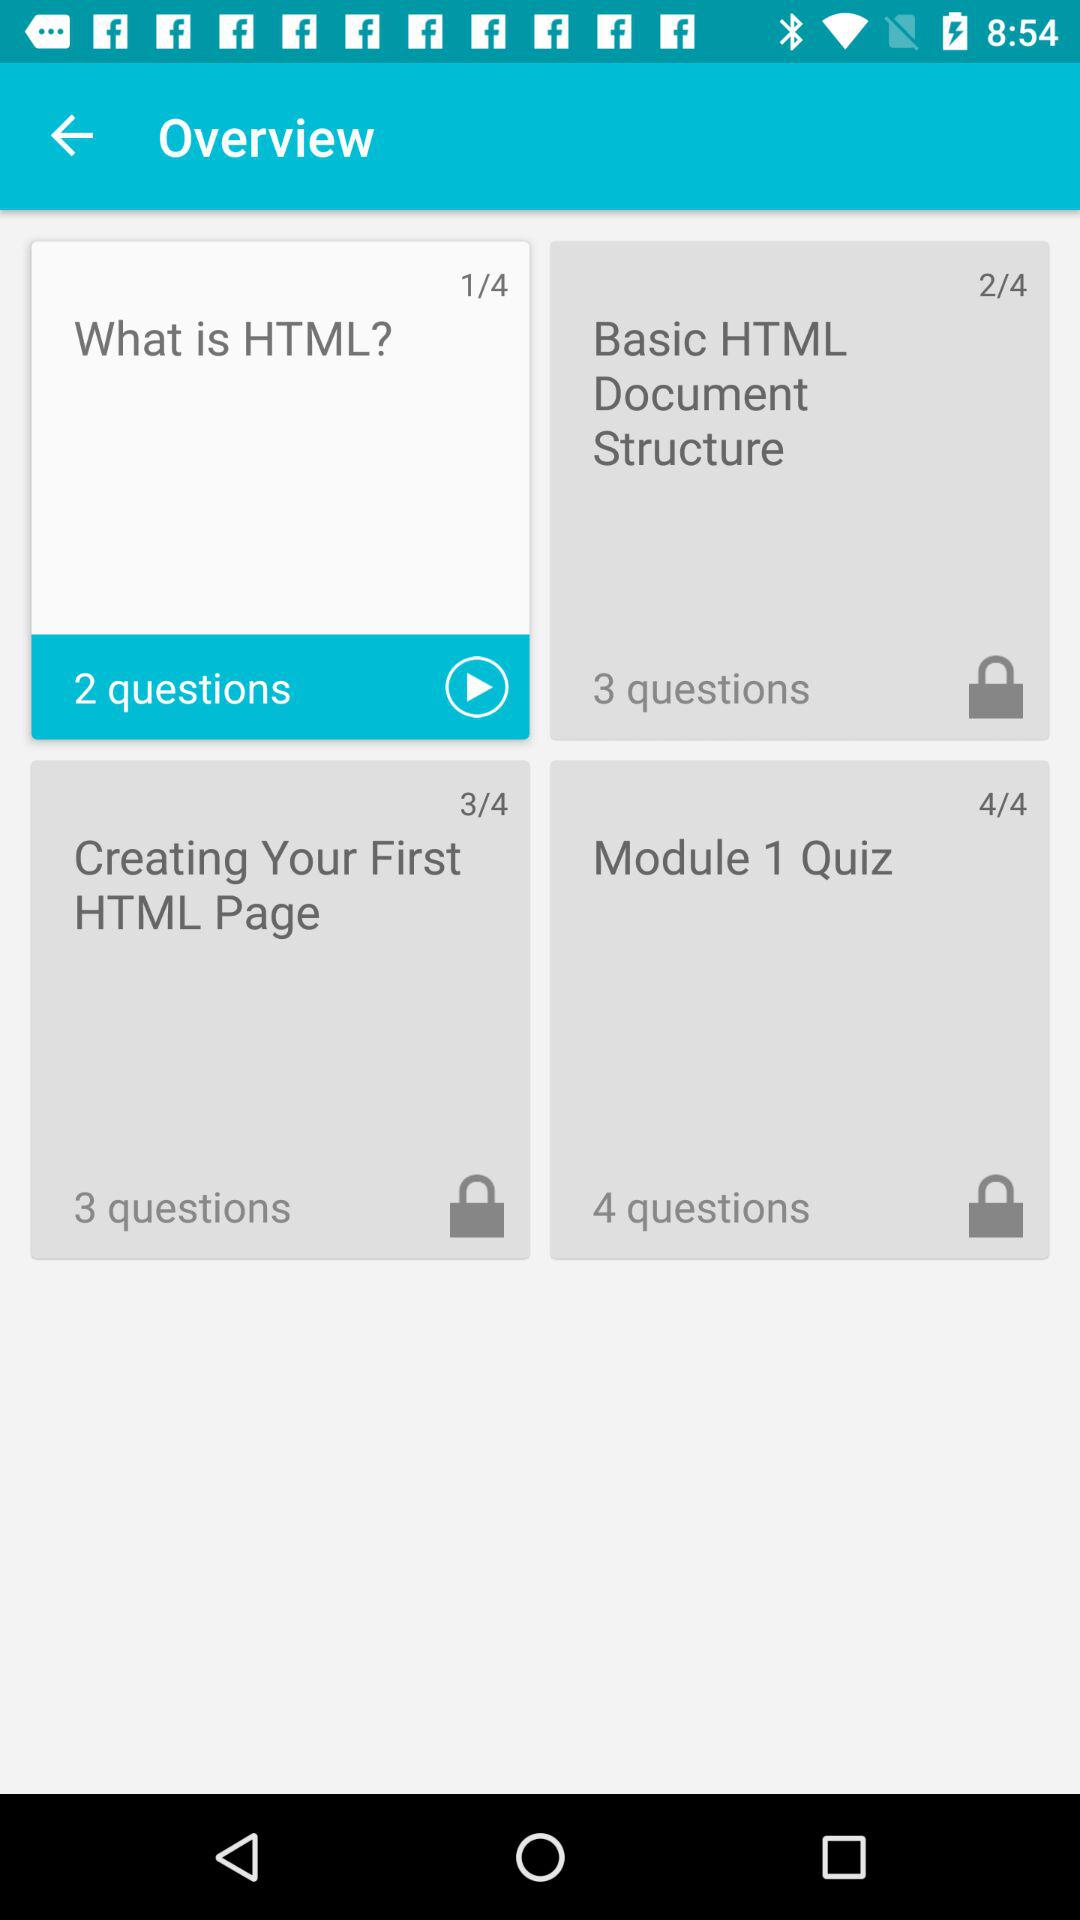How many more questions are there in the Module 1 Quiz than in the Basic HTML Document Structure section?
Answer the question using a single word or phrase. 1 